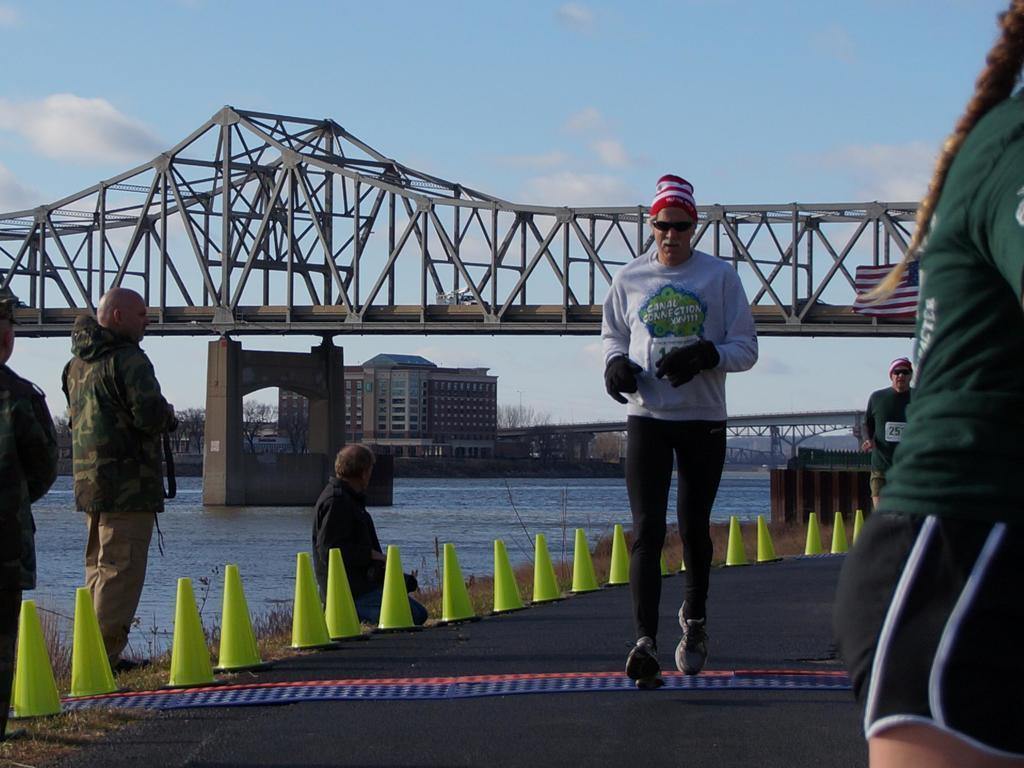Please provide a concise description of this image. This is an outside view. On the right side, I can see two men and a woman are running on the road. Beside the road few people standing and one person is sitting. In the background there is a river and I can see a bridge. In the background there are some buildings. At the top I can see the sky. 